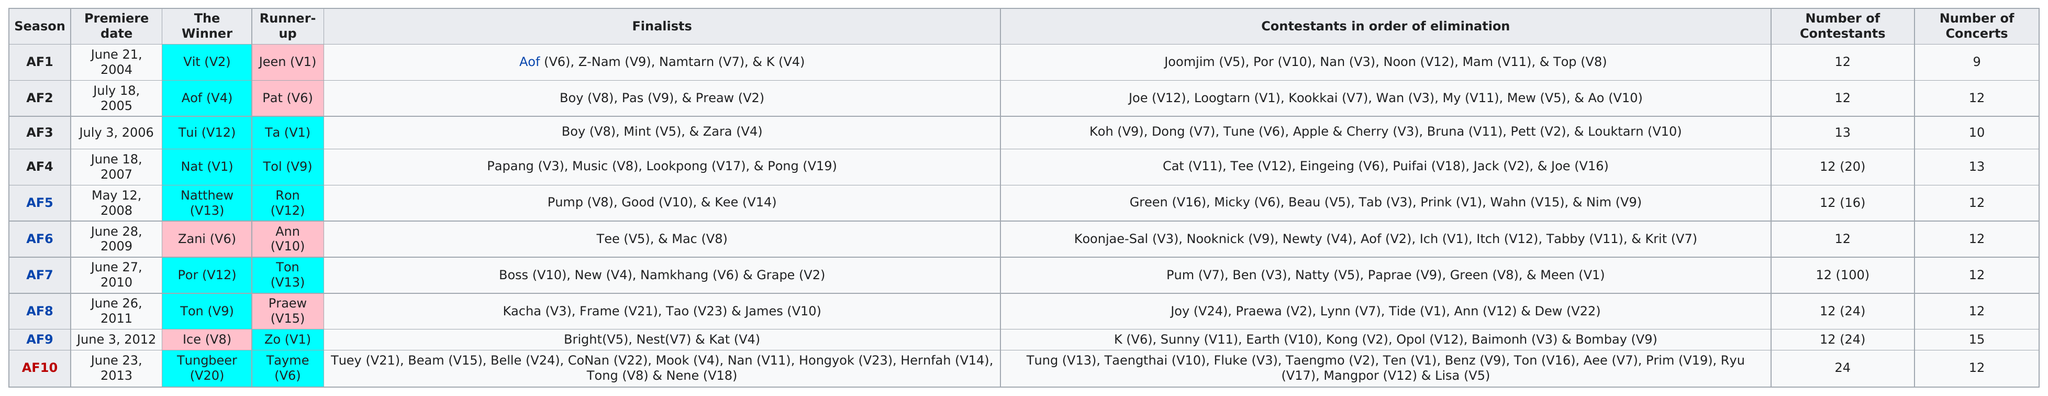Highlight a few significant elements in this photo. There were four finalists in the first season. The last premier date of "Academy Fantasia" was on June 23, 2013. The least number of concerts given in a season is 9. The latest winner was Tungbeer (V20). On June 3, 2012, there were 12 contestants. Additionally, there were 24 contestants in total. 